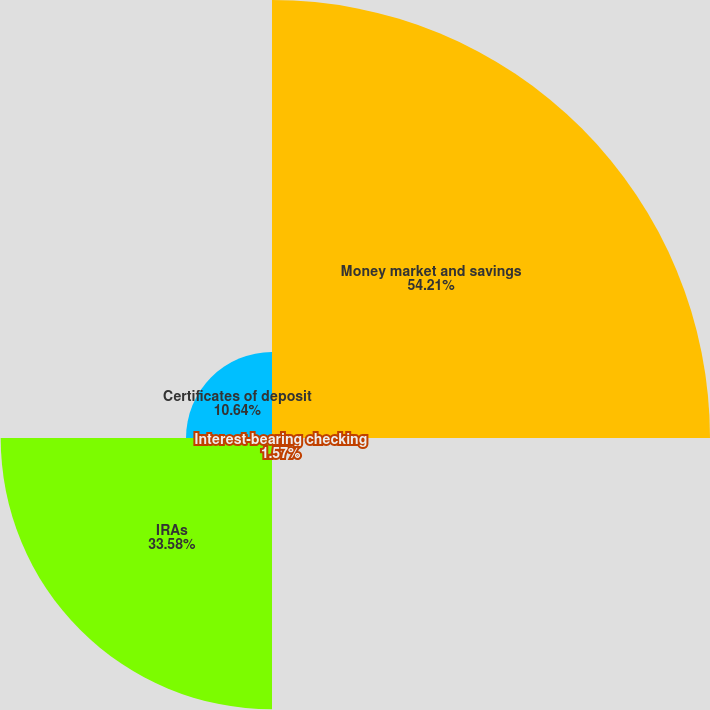Convert chart to OTSL. <chart><loc_0><loc_0><loc_500><loc_500><pie_chart><fcel>Money market and savings<fcel>Interest-bearing checking<fcel>IRAs<fcel>Certificates of deposit<nl><fcel>54.21%<fcel>1.57%<fcel>33.58%<fcel>10.64%<nl></chart> 